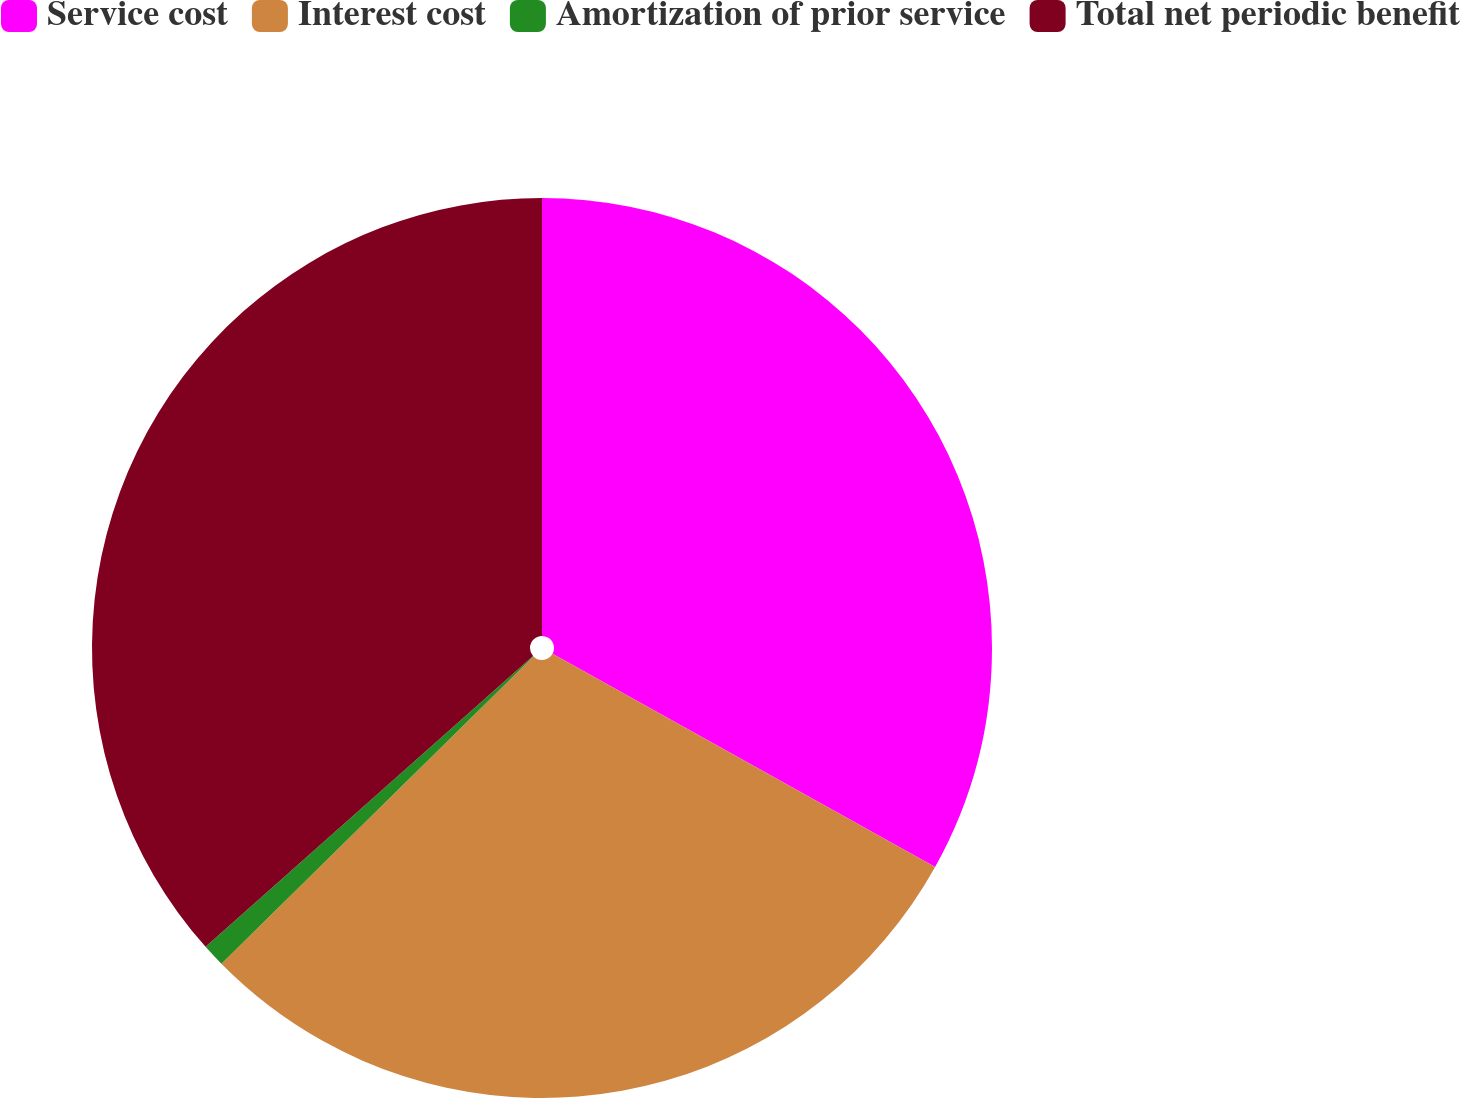<chart> <loc_0><loc_0><loc_500><loc_500><pie_chart><fcel>Service cost<fcel>Interest cost<fcel>Amortization of prior service<fcel>Total net periodic benefit<nl><fcel>33.09%<fcel>29.53%<fcel>0.82%<fcel>36.56%<nl></chart> 